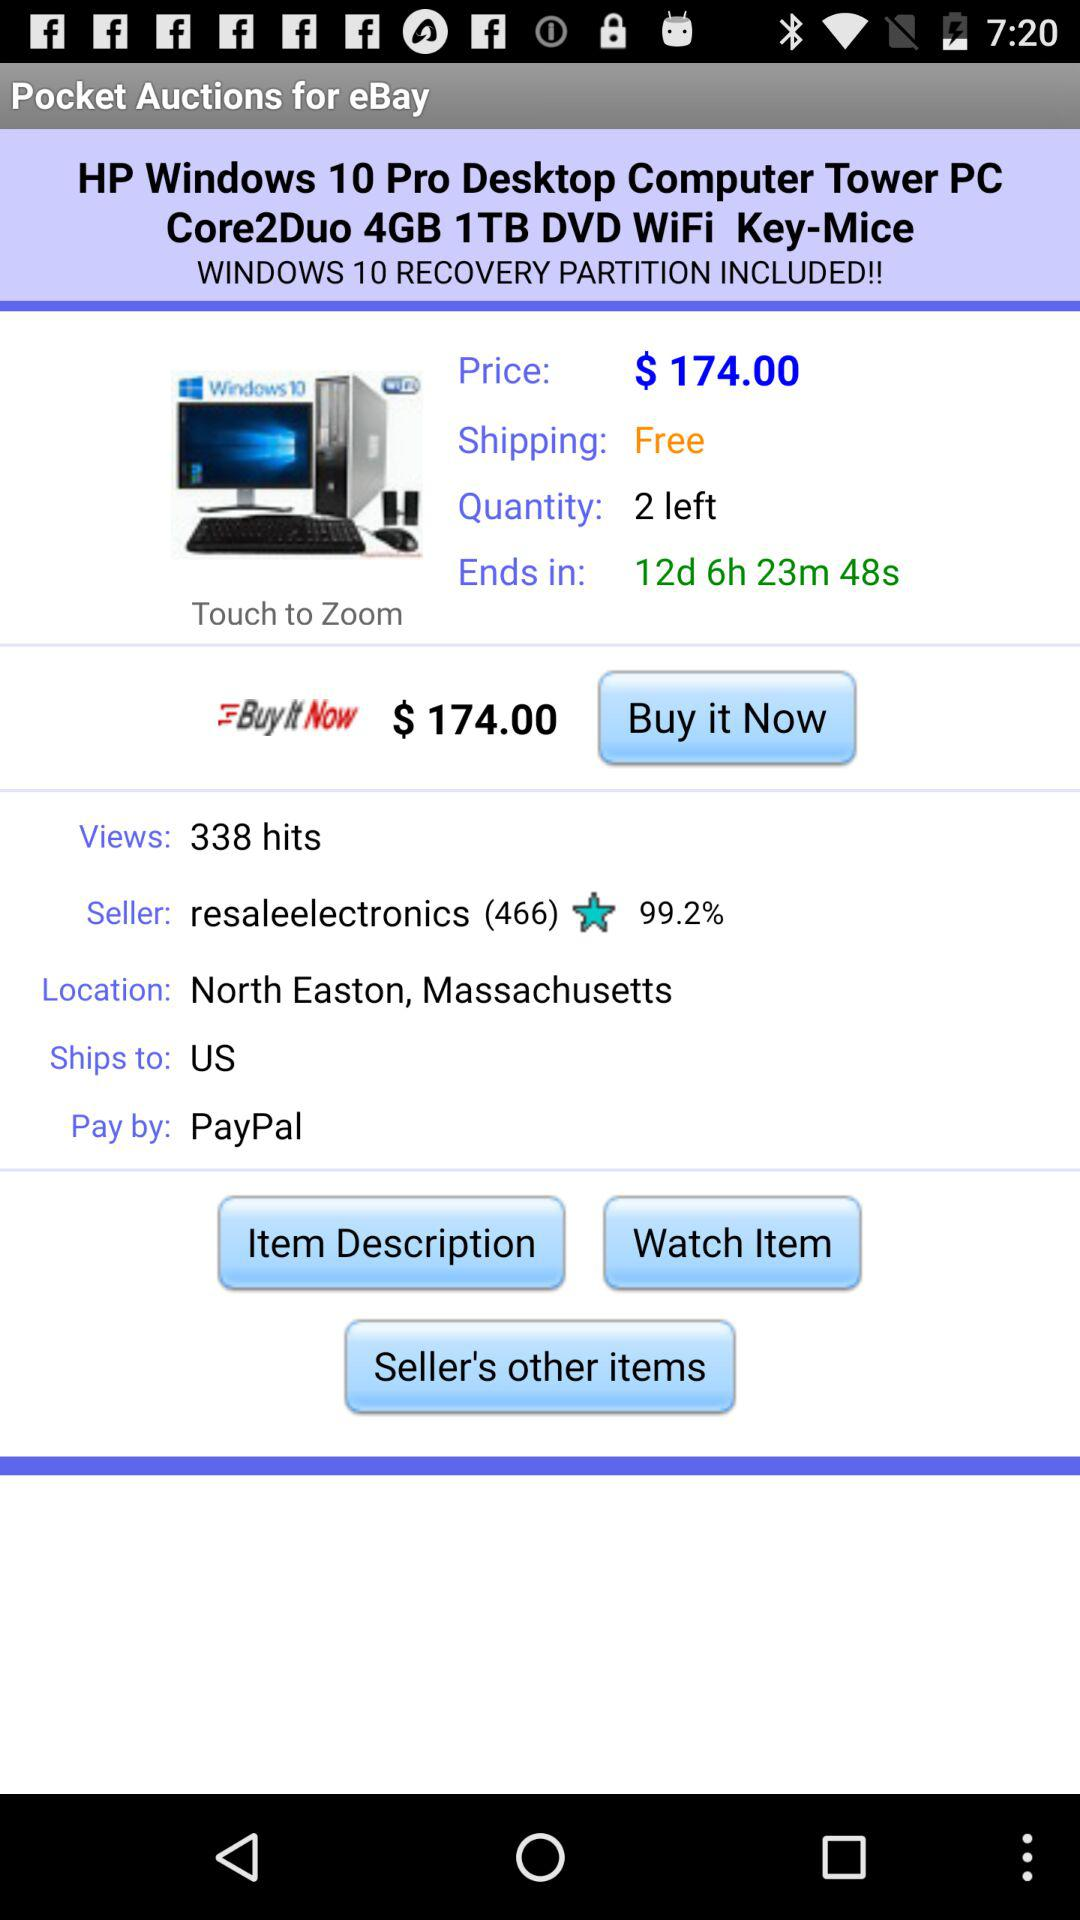How many views are there? There are 338 views. 